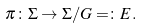Convert formula to latex. <formula><loc_0><loc_0><loc_500><loc_500>\pi \colon \Sigma \rightarrow \Sigma / G = \colon E .</formula> 